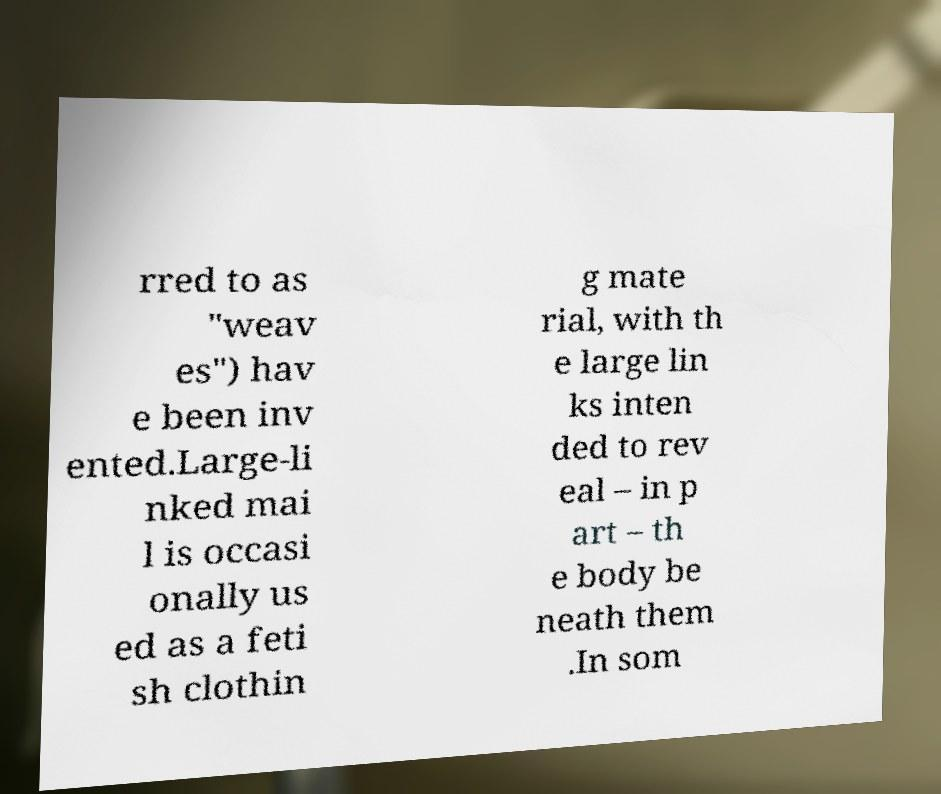Please read and relay the text visible in this image. What does it say? rred to as "weav es") hav e been inv ented.Large-li nked mai l is occasi onally us ed as a feti sh clothin g mate rial, with th e large lin ks inten ded to rev eal – in p art – th e body be neath them .In som 